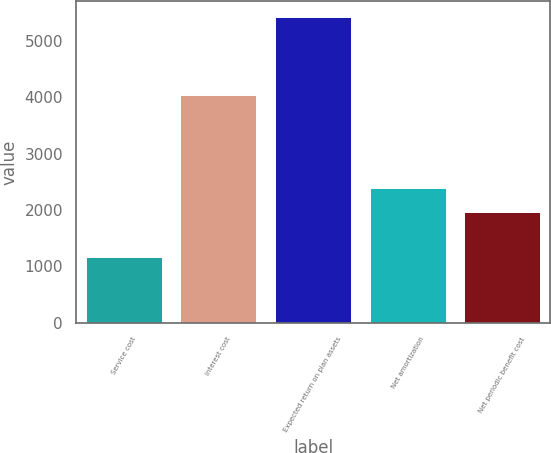Convert chart. <chart><loc_0><loc_0><loc_500><loc_500><bar_chart><fcel>Service cost<fcel>Interest cost<fcel>Expected return on plan assets<fcel>Net amortization<fcel>Net periodic benefit cost<nl><fcel>1162<fcel>4037<fcel>5430<fcel>2382.8<fcel>1956<nl></chart> 